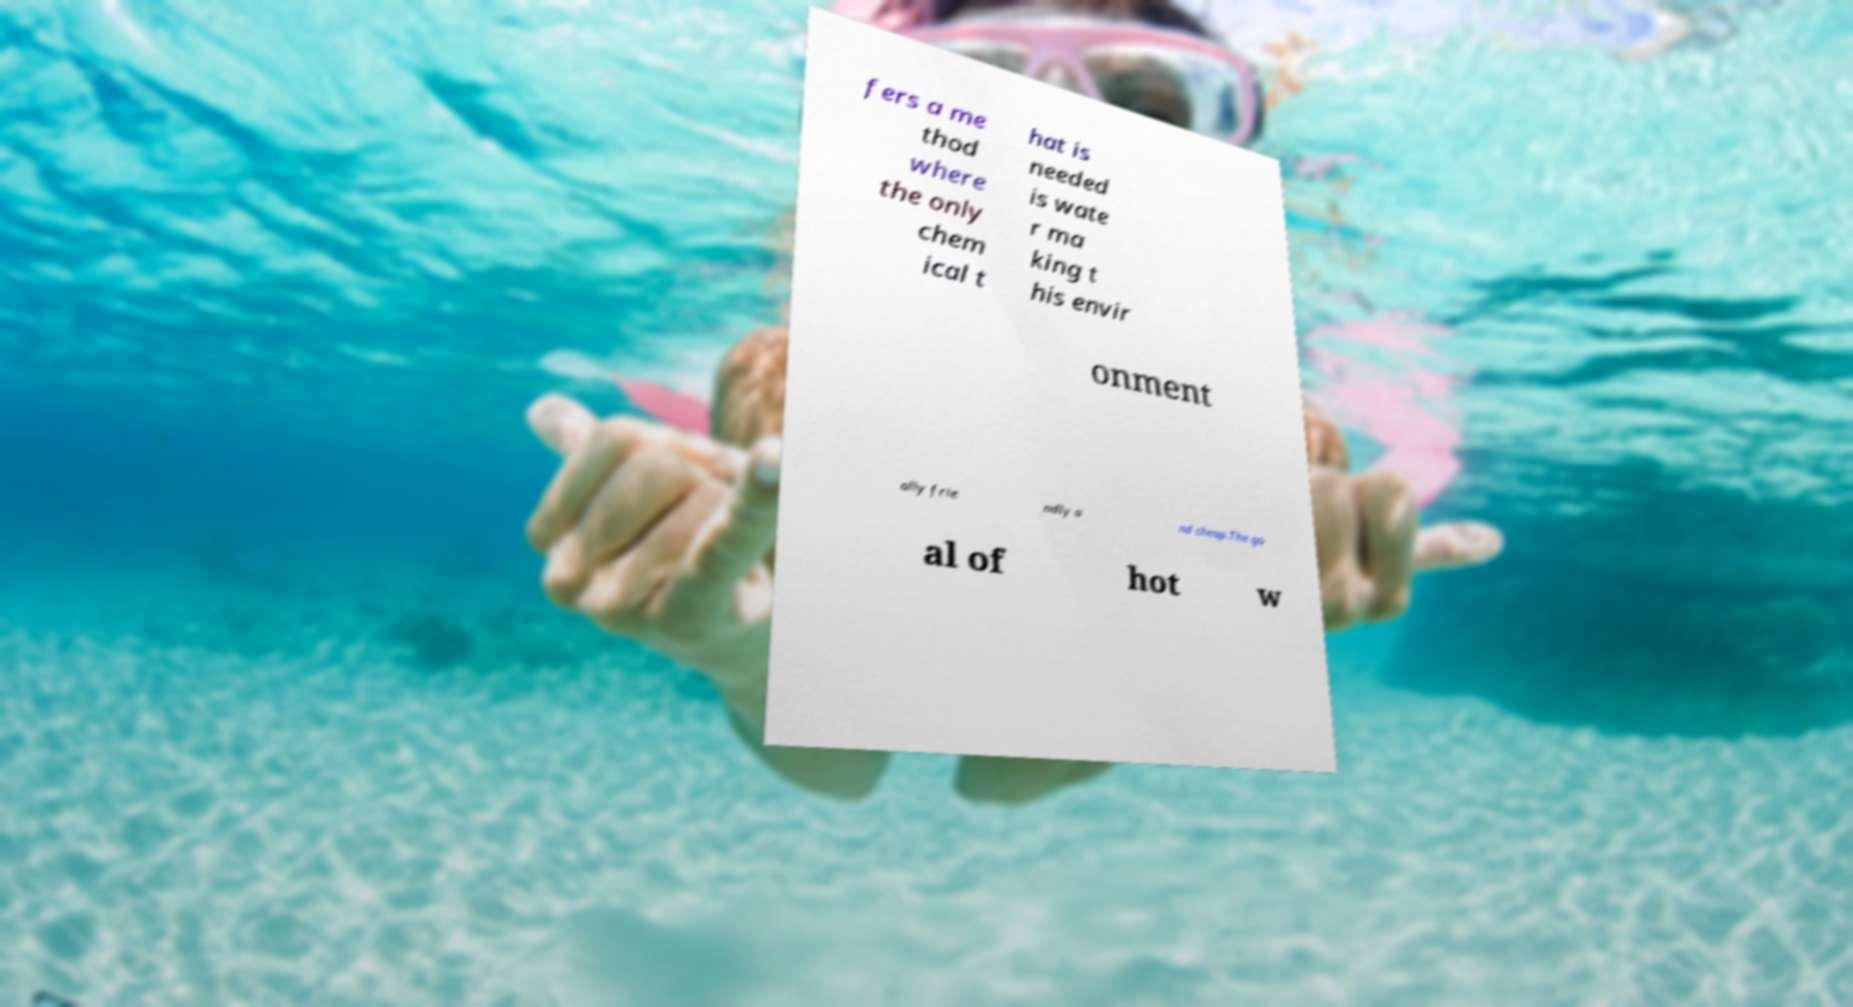Please identify and transcribe the text found in this image. fers a me thod where the only chem ical t hat is needed is wate r ma king t his envir onment ally frie ndly a nd cheap.The go al of hot w 